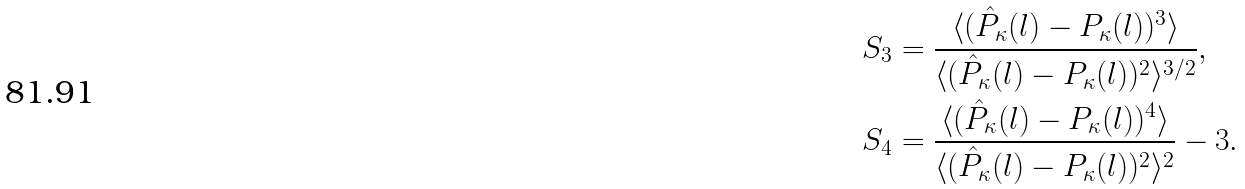Convert formula to latex. <formula><loc_0><loc_0><loc_500><loc_500>& S _ { 3 } = \frac { \langle ( \hat { P } _ { \kappa } ( l ) - P _ { \kappa } ( l ) ) ^ { 3 } \rangle } { \langle ( \hat { P } _ { \kappa } ( l ) - P _ { \kappa } ( l ) ) ^ { 2 } \rangle ^ { 3 / 2 } } , \\ & S _ { 4 } = \frac { \langle ( \hat { P } _ { \kappa } ( l ) - P _ { \kappa } ( l ) ) ^ { 4 } \rangle } { \langle ( \hat { P } _ { \kappa } ( l ) - P _ { \kappa } ( l ) ) ^ { 2 } \rangle ^ { 2 } } - 3 .</formula> 